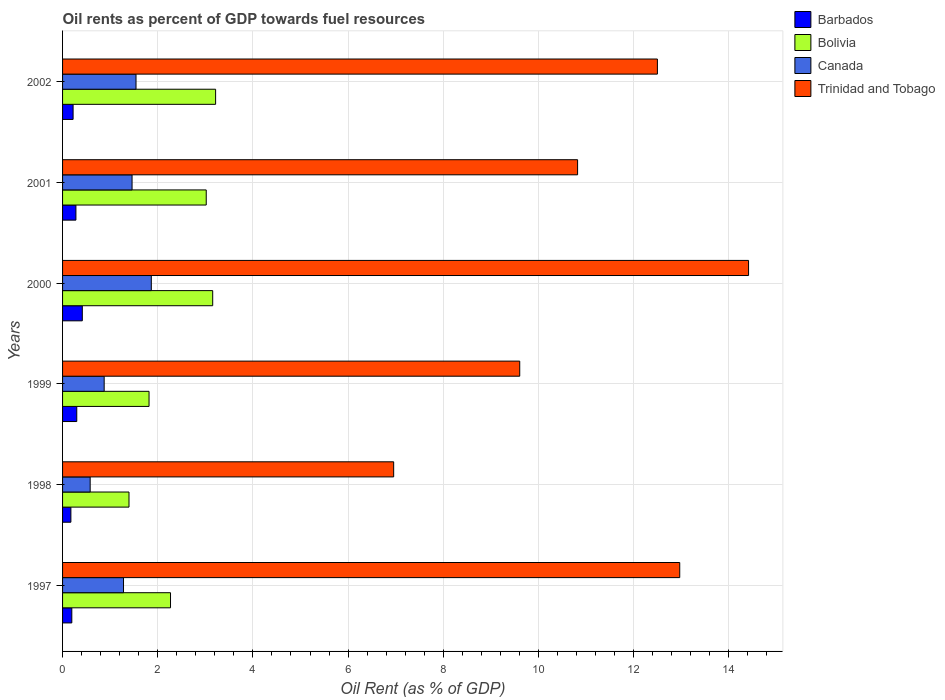Are the number of bars per tick equal to the number of legend labels?
Your answer should be very brief. Yes. Are the number of bars on each tick of the Y-axis equal?
Your answer should be compact. Yes. What is the label of the 5th group of bars from the top?
Make the answer very short. 1998. In how many cases, is the number of bars for a given year not equal to the number of legend labels?
Keep it short and to the point. 0. What is the oil rent in Bolivia in 2002?
Provide a short and direct response. 3.22. Across all years, what is the maximum oil rent in Bolivia?
Your answer should be compact. 3.22. Across all years, what is the minimum oil rent in Canada?
Provide a succinct answer. 0.58. In which year was the oil rent in Barbados maximum?
Ensure brevity in your answer.  2000. In which year was the oil rent in Barbados minimum?
Offer a terse response. 1998. What is the total oil rent in Bolivia in the graph?
Ensure brevity in your answer.  14.87. What is the difference between the oil rent in Barbados in 1997 and that in 2000?
Ensure brevity in your answer.  -0.22. What is the difference between the oil rent in Bolivia in 1997 and the oil rent in Canada in 2001?
Make the answer very short. 0.81. What is the average oil rent in Barbados per year?
Your answer should be very brief. 0.26. In the year 1999, what is the difference between the oil rent in Canada and oil rent in Barbados?
Keep it short and to the point. 0.58. What is the ratio of the oil rent in Bolivia in 1999 to that in 2002?
Your answer should be compact. 0.57. What is the difference between the highest and the second highest oil rent in Barbados?
Offer a very short reply. 0.12. What is the difference between the highest and the lowest oil rent in Trinidad and Tobago?
Ensure brevity in your answer.  7.46. In how many years, is the oil rent in Barbados greater than the average oil rent in Barbados taken over all years?
Ensure brevity in your answer.  3. Is it the case that in every year, the sum of the oil rent in Bolivia and oil rent in Canada is greater than the sum of oil rent in Barbados and oil rent in Trinidad and Tobago?
Ensure brevity in your answer.  Yes. How many bars are there?
Offer a terse response. 24. How many years are there in the graph?
Provide a succinct answer. 6. What is the difference between two consecutive major ticks on the X-axis?
Ensure brevity in your answer.  2. Are the values on the major ticks of X-axis written in scientific E-notation?
Make the answer very short. No. Does the graph contain any zero values?
Your answer should be compact. No. Where does the legend appear in the graph?
Give a very brief answer. Top right. How many legend labels are there?
Provide a succinct answer. 4. How are the legend labels stacked?
Provide a short and direct response. Vertical. What is the title of the graph?
Your answer should be very brief. Oil rents as percent of GDP towards fuel resources. Does "Bahamas" appear as one of the legend labels in the graph?
Provide a succinct answer. No. What is the label or title of the X-axis?
Your answer should be compact. Oil Rent (as % of GDP). What is the Oil Rent (as % of GDP) of Barbados in 1997?
Make the answer very short. 0.19. What is the Oil Rent (as % of GDP) of Bolivia in 1997?
Provide a succinct answer. 2.27. What is the Oil Rent (as % of GDP) of Canada in 1997?
Provide a short and direct response. 1.28. What is the Oil Rent (as % of GDP) of Trinidad and Tobago in 1997?
Your response must be concise. 12.97. What is the Oil Rent (as % of GDP) of Barbados in 1998?
Your response must be concise. 0.18. What is the Oil Rent (as % of GDP) in Bolivia in 1998?
Give a very brief answer. 1.4. What is the Oil Rent (as % of GDP) in Canada in 1998?
Keep it short and to the point. 0.58. What is the Oil Rent (as % of GDP) in Trinidad and Tobago in 1998?
Provide a succinct answer. 6.96. What is the Oil Rent (as % of GDP) in Barbados in 1999?
Provide a short and direct response. 0.3. What is the Oil Rent (as % of GDP) of Bolivia in 1999?
Keep it short and to the point. 1.82. What is the Oil Rent (as % of GDP) in Canada in 1999?
Offer a terse response. 0.87. What is the Oil Rent (as % of GDP) in Trinidad and Tobago in 1999?
Ensure brevity in your answer.  9.61. What is the Oil Rent (as % of GDP) of Barbados in 2000?
Your answer should be compact. 0.41. What is the Oil Rent (as % of GDP) in Bolivia in 2000?
Give a very brief answer. 3.16. What is the Oil Rent (as % of GDP) of Canada in 2000?
Provide a short and direct response. 1.87. What is the Oil Rent (as % of GDP) in Trinidad and Tobago in 2000?
Make the answer very short. 14.42. What is the Oil Rent (as % of GDP) in Barbados in 2001?
Your answer should be compact. 0.28. What is the Oil Rent (as % of GDP) in Bolivia in 2001?
Give a very brief answer. 3.02. What is the Oil Rent (as % of GDP) in Canada in 2001?
Your answer should be compact. 1.46. What is the Oil Rent (as % of GDP) of Trinidad and Tobago in 2001?
Give a very brief answer. 10.82. What is the Oil Rent (as % of GDP) in Barbados in 2002?
Your answer should be compact. 0.22. What is the Oil Rent (as % of GDP) in Bolivia in 2002?
Provide a short and direct response. 3.22. What is the Oil Rent (as % of GDP) in Canada in 2002?
Ensure brevity in your answer.  1.54. What is the Oil Rent (as % of GDP) of Trinidad and Tobago in 2002?
Offer a terse response. 12.5. Across all years, what is the maximum Oil Rent (as % of GDP) of Barbados?
Offer a very short reply. 0.41. Across all years, what is the maximum Oil Rent (as % of GDP) in Bolivia?
Provide a short and direct response. 3.22. Across all years, what is the maximum Oil Rent (as % of GDP) in Canada?
Your answer should be compact. 1.87. Across all years, what is the maximum Oil Rent (as % of GDP) of Trinidad and Tobago?
Ensure brevity in your answer.  14.42. Across all years, what is the minimum Oil Rent (as % of GDP) in Barbados?
Give a very brief answer. 0.18. Across all years, what is the minimum Oil Rent (as % of GDP) in Bolivia?
Ensure brevity in your answer.  1.4. Across all years, what is the minimum Oil Rent (as % of GDP) of Canada?
Ensure brevity in your answer.  0.58. Across all years, what is the minimum Oil Rent (as % of GDP) of Trinidad and Tobago?
Offer a terse response. 6.96. What is the total Oil Rent (as % of GDP) of Barbados in the graph?
Your answer should be very brief. 1.58. What is the total Oil Rent (as % of GDP) of Bolivia in the graph?
Offer a very short reply. 14.87. What is the total Oil Rent (as % of GDP) of Canada in the graph?
Ensure brevity in your answer.  7.6. What is the total Oil Rent (as % of GDP) of Trinidad and Tobago in the graph?
Ensure brevity in your answer.  67.28. What is the difference between the Oil Rent (as % of GDP) of Barbados in 1997 and that in 1998?
Your response must be concise. 0.02. What is the difference between the Oil Rent (as % of GDP) of Bolivia in 1997 and that in 1998?
Keep it short and to the point. 0.87. What is the difference between the Oil Rent (as % of GDP) in Canada in 1997 and that in 1998?
Make the answer very short. 0.7. What is the difference between the Oil Rent (as % of GDP) of Trinidad and Tobago in 1997 and that in 1998?
Your answer should be compact. 6.01. What is the difference between the Oil Rent (as % of GDP) in Barbados in 1997 and that in 1999?
Ensure brevity in your answer.  -0.1. What is the difference between the Oil Rent (as % of GDP) in Bolivia in 1997 and that in 1999?
Ensure brevity in your answer.  0.45. What is the difference between the Oil Rent (as % of GDP) of Canada in 1997 and that in 1999?
Your answer should be very brief. 0.41. What is the difference between the Oil Rent (as % of GDP) in Trinidad and Tobago in 1997 and that in 1999?
Offer a very short reply. 3.36. What is the difference between the Oil Rent (as % of GDP) in Barbados in 1997 and that in 2000?
Provide a succinct answer. -0.22. What is the difference between the Oil Rent (as % of GDP) in Bolivia in 1997 and that in 2000?
Your answer should be compact. -0.89. What is the difference between the Oil Rent (as % of GDP) of Canada in 1997 and that in 2000?
Your response must be concise. -0.58. What is the difference between the Oil Rent (as % of GDP) in Trinidad and Tobago in 1997 and that in 2000?
Your answer should be very brief. -1.45. What is the difference between the Oil Rent (as % of GDP) in Barbados in 1997 and that in 2001?
Give a very brief answer. -0.09. What is the difference between the Oil Rent (as % of GDP) in Bolivia in 1997 and that in 2001?
Offer a terse response. -0.75. What is the difference between the Oil Rent (as % of GDP) in Canada in 1997 and that in 2001?
Keep it short and to the point. -0.18. What is the difference between the Oil Rent (as % of GDP) of Trinidad and Tobago in 1997 and that in 2001?
Offer a terse response. 2.15. What is the difference between the Oil Rent (as % of GDP) in Barbados in 1997 and that in 2002?
Offer a terse response. -0.03. What is the difference between the Oil Rent (as % of GDP) in Bolivia in 1997 and that in 2002?
Give a very brief answer. -0.95. What is the difference between the Oil Rent (as % of GDP) in Canada in 1997 and that in 2002?
Offer a very short reply. -0.26. What is the difference between the Oil Rent (as % of GDP) in Trinidad and Tobago in 1997 and that in 2002?
Your answer should be very brief. 0.47. What is the difference between the Oil Rent (as % of GDP) in Barbados in 1998 and that in 1999?
Your answer should be compact. -0.12. What is the difference between the Oil Rent (as % of GDP) of Bolivia in 1998 and that in 1999?
Your response must be concise. -0.42. What is the difference between the Oil Rent (as % of GDP) in Canada in 1998 and that in 1999?
Make the answer very short. -0.29. What is the difference between the Oil Rent (as % of GDP) in Trinidad and Tobago in 1998 and that in 1999?
Offer a terse response. -2.65. What is the difference between the Oil Rent (as % of GDP) in Barbados in 1998 and that in 2000?
Offer a very short reply. -0.24. What is the difference between the Oil Rent (as % of GDP) in Bolivia in 1998 and that in 2000?
Your answer should be compact. -1.76. What is the difference between the Oil Rent (as % of GDP) of Canada in 1998 and that in 2000?
Ensure brevity in your answer.  -1.28. What is the difference between the Oil Rent (as % of GDP) of Trinidad and Tobago in 1998 and that in 2000?
Offer a very short reply. -7.46. What is the difference between the Oil Rent (as % of GDP) in Barbados in 1998 and that in 2001?
Provide a short and direct response. -0.11. What is the difference between the Oil Rent (as % of GDP) in Bolivia in 1998 and that in 2001?
Your answer should be very brief. -1.62. What is the difference between the Oil Rent (as % of GDP) of Canada in 1998 and that in 2001?
Your response must be concise. -0.88. What is the difference between the Oil Rent (as % of GDP) of Trinidad and Tobago in 1998 and that in 2001?
Offer a very short reply. -3.87. What is the difference between the Oil Rent (as % of GDP) of Barbados in 1998 and that in 2002?
Offer a terse response. -0.05. What is the difference between the Oil Rent (as % of GDP) of Bolivia in 1998 and that in 2002?
Offer a terse response. -1.82. What is the difference between the Oil Rent (as % of GDP) in Canada in 1998 and that in 2002?
Make the answer very short. -0.96. What is the difference between the Oil Rent (as % of GDP) of Trinidad and Tobago in 1998 and that in 2002?
Ensure brevity in your answer.  -5.54. What is the difference between the Oil Rent (as % of GDP) of Barbados in 1999 and that in 2000?
Your answer should be very brief. -0.12. What is the difference between the Oil Rent (as % of GDP) of Bolivia in 1999 and that in 2000?
Your response must be concise. -1.34. What is the difference between the Oil Rent (as % of GDP) of Canada in 1999 and that in 2000?
Your response must be concise. -0.99. What is the difference between the Oil Rent (as % of GDP) of Trinidad and Tobago in 1999 and that in 2000?
Make the answer very short. -4.81. What is the difference between the Oil Rent (as % of GDP) in Barbados in 1999 and that in 2001?
Offer a very short reply. 0.02. What is the difference between the Oil Rent (as % of GDP) of Bolivia in 1999 and that in 2001?
Make the answer very short. -1.2. What is the difference between the Oil Rent (as % of GDP) in Canada in 1999 and that in 2001?
Make the answer very short. -0.59. What is the difference between the Oil Rent (as % of GDP) in Trinidad and Tobago in 1999 and that in 2001?
Your response must be concise. -1.22. What is the difference between the Oil Rent (as % of GDP) in Barbados in 1999 and that in 2002?
Make the answer very short. 0.08. What is the difference between the Oil Rent (as % of GDP) in Bolivia in 1999 and that in 2002?
Ensure brevity in your answer.  -1.4. What is the difference between the Oil Rent (as % of GDP) in Canada in 1999 and that in 2002?
Offer a very short reply. -0.67. What is the difference between the Oil Rent (as % of GDP) in Trinidad and Tobago in 1999 and that in 2002?
Your response must be concise. -2.89. What is the difference between the Oil Rent (as % of GDP) of Barbados in 2000 and that in 2001?
Keep it short and to the point. 0.13. What is the difference between the Oil Rent (as % of GDP) of Bolivia in 2000 and that in 2001?
Your response must be concise. 0.14. What is the difference between the Oil Rent (as % of GDP) of Canada in 2000 and that in 2001?
Ensure brevity in your answer.  0.4. What is the difference between the Oil Rent (as % of GDP) in Trinidad and Tobago in 2000 and that in 2001?
Keep it short and to the point. 3.59. What is the difference between the Oil Rent (as % of GDP) of Barbados in 2000 and that in 2002?
Offer a very short reply. 0.19. What is the difference between the Oil Rent (as % of GDP) of Bolivia in 2000 and that in 2002?
Offer a terse response. -0.06. What is the difference between the Oil Rent (as % of GDP) in Canada in 2000 and that in 2002?
Offer a terse response. 0.32. What is the difference between the Oil Rent (as % of GDP) in Trinidad and Tobago in 2000 and that in 2002?
Offer a terse response. 1.92. What is the difference between the Oil Rent (as % of GDP) in Barbados in 2001 and that in 2002?
Keep it short and to the point. 0.06. What is the difference between the Oil Rent (as % of GDP) in Bolivia in 2001 and that in 2002?
Your answer should be compact. -0.2. What is the difference between the Oil Rent (as % of GDP) of Canada in 2001 and that in 2002?
Ensure brevity in your answer.  -0.08. What is the difference between the Oil Rent (as % of GDP) in Trinidad and Tobago in 2001 and that in 2002?
Your answer should be compact. -1.68. What is the difference between the Oil Rent (as % of GDP) in Barbados in 1997 and the Oil Rent (as % of GDP) in Bolivia in 1998?
Offer a very short reply. -1.2. What is the difference between the Oil Rent (as % of GDP) in Barbados in 1997 and the Oil Rent (as % of GDP) in Canada in 1998?
Offer a very short reply. -0.39. What is the difference between the Oil Rent (as % of GDP) of Barbados in 1997 and the Oil Rent (as % of GDP) of Trinidad and Tobago in 1998?
Make the answer very short. -6.76. What is the difference between the Oil Rent (as % of GDP) of Bolivia in 1997 and the Oil Rent (as % of GDP) of Canada in 1998?
Offer a terse response. 1.69. What is the difference between the Oil Rent (as % of GDP) of Bolivia in 1997 and the Oil Rent (as % of GDP) of Trinidad and Tobago in 1998?
Keep it short and to the point. -4.69. What is the difference between the Oil Rent (as % of GDP) of Canada in 1997 and the Oil Rent (as % of GDP) of Trinidad and Tobago in 1998?
Give a very brief answer. -5.68. What is the difference between the Oil Rent (as % of GDP) of Barbados in 1997 and the Oil Rent (as % of GDP) of Bolivia in 1999?
Provide a succinct answer. -1.62. What is the difference between the Oil Rent (as % of GDP) in Barbados in 1997 and the Oil Rent (as % of GDP) in Canada in 1999?
Provide a succinct answer. -0.68. What is the difference between the Oil Rent (as % of GDP) in Barbados in 1997 and the Oil Rent (as % of GDP) in Trinidad and Tobago in 1999?
Make the answer very short. -9.41. What is the difference between the Oil Rent (as % of GDP) in Bolivia in 1997 and the Oil Rent (as % of GDP) in Canada in 1999?
Make the answer very short. 1.39. What is the difference between the Oil Rent (as % of GDP) of Bolivia in 1997 and the Oil Rent (as % of GDP) of Trinidad and Tobago in 1999?
Offer a terse response. -7.34. What is the difference between the Oil Rent (as % of GDP) in Canada in 1997 and the Oil Rent (as % of GDP) in Trinidad and Tobago in 1999?
Offer a terse response. -8.33. What is the difference between the Oil Rent (as % of GDP) of Barbados in 1997 and the Oil Rent (as % of GDP) of Bolivia in 2000?
Provide a succinct answer. -2.96. What is the difference between the Oil Rent (as % of GDP) of Barbados in 1997 and the Oil Rent (as % of GDP) of Canada in 2000?
Provide a short and direct response. -1.67. What is the difference between the Oil Rent (as % of GDP) in Barbados in 1997 and the Oil Rent (as % of GDP) in Trinidad and Tobago in 2000?
Offer a terse response. -14.22. What is the difference between the Oil Rent (as % of GDP) of Bolivia in 1997 and the Oil Rent (as % of GDP) of Canada in 2000?
Your response must be concise. 0.4. What is the difference between the Oil Rent (as % of GDP) of Bolivia in 1997 and the Oil Rent (as % of GDP) of Trinidad and Tobago in 2000?
Provide a succinct answer. -12.15. What is the difference between the Oil Rent (as % of GDP) in Canada in 1997 and the Oil Rent (as % of GDP) in Trinidad and Tobago in 2000?
Provide a short and direct response. -13.14. What is the difference between the Oil Rent (as % of GDP) of Barbados in 1997 and the Oil Rent (as % of GDP) of Bolivia in 2001?
Your response must be concise. -2.83. What is the difference between the Oil Rent (as % of GDP) of Barbados in 1997 and the Oil Rent (as % of GDP) of Canada in 2001?
Your response must be concise. -1.27. What is the difference between the Oil Rent (as % of GDP) of Barbados in 1997 and the Oil Rent (as % of GDP) of Trinidad and Tobago in 2001?
Make the answer very short. -10.63. What is the difference between the Oil Rent (as % of GDP) of Bolivia in 1997 and the Oil Rent (as % of GDP) of Canada in 2001?
Offer a terse response. 0.81. What is the difference between the Oil Rent (as % of GDP) of Bolivia in 1997 and the Oil Rent (as % of GDP) of Trinidad and Tobago in 2001?
Provide a short and direct response. -8.56. What is the difference between the Oil Rent (as % of GDP) in Canada in 1997 and the Oil Rent (as % of GDP) in Trinidad and Tobago in 2001?
Your response must be concise. -9.54. What is the difference between the Oil Rent (as % of GDP) of Barbados in 1997 and the Oil Rent (as % of GDP) of Bolivia in 2002?
Ensure brevity in your answer.  -3.02. What is the difference between the Oil Rent (as % of GDP) in Barbados in 1997 and the Oil Rent (as % of GDP) in Canada in 2002?
Your response must be concise. -1.35. What is the difference between the Oil Rent (as % of GDP) of Barbados in 1997 and the Oil Rent (as % of GDP) of Trinidad and Tobago in 2002?
Provide a succinct answer. -12.31. What is the difference between the Oil Rent (as % of GDP) in Bolivia in 1997 and the Oil Rent (as % of GDP) in Canada in 2002?
Your response must be concise. 0.72. What is the difference between the Oil Rent (as % of GDP) in Bolivia in 1997 and the Oil Rent (as % of GDP) in Trinidad and Tobago in 2002?
Your answer should be compact. -10.23. What is the difference between the Oil Rent (as % of GDP) of Canada in 1997 and the Oil Rent (as % of GDP) of Trinidad and Tobago in 2002?
Provide a succinct answer. -11.22. What is the difference between the Oil Rent (as % of GDP) of Barbados in 1998 and the Oil Rent (as % of GDP) of Bolivia in 1999?
Keep it short and to the point. -1.64. What is the difference between the Oil Rent (as % of GDP) of Barbados in 1998 and the Oil Rent (as % of GDP) of Canada in 1999?
Provide a succinct answer. -0.7. What is the difference between the Oil Rent (as % of GDP) of Barbados in 1998 and the Oil Rent (as % of GDP) of Trinidad and Tobago in 1999?
Ensure brevity in your answer.  -9.43. What is the difference between the Oil Rent (as % of GDP) in Bolivia in 1998 and the Oil Rent (as % of GDP) in Canada in 1999?
Your answer should be very brief. 0.52. What is the difference between the Oil Rent (as % of GDP) of Bolivia in 1998 and the Oil Rent (as % of GDP) of Trinidad and Tobago in 1999?
Make the answer very short. -8.21. What is the difference between the Oil Rent (as % of GDP) of Canada in 1998 and the Oil Rent (as % of GDP) of Trinidad and Tobago in 1999?
Provide a succinct answer. -9.03. What is the difference between the Oil Rent (as % of GDP) of Barbados in 1998 and the Oil Rent (as % of GDP) of Bolivia in 2000?
Provide a short and direct response. -2.98. What is the difference between the Oil Rent (as % of GDP) of Barbados in 1998 and the Oil Rent (as % of GDP) of Canada in 2000?
Provide a succinct answer. -1.69. What is the difference between the Oil Rent (as % of GDP) in Barbados in 1998 and the Oil Rent (as % of GDP) in Trinidad and Tobago in 2000?
Provide a succinct answer. -14.24. What is the difference between the Oil Rent (as % of GDP) in Bolivia in 1998 and the Oil Rent (as % of GDP) in Canada in 2000?
Your answer should be compact. -0.47. What is the difference between the Oil Rent (as % of GDP) in Bolivia in 1998 and the Oil Rent (as % of GDP) in Trinidad and Tobago in 2000?
Provide a succinct answer. -13.02. What is the difference between the Oil Rent (as % of GDP) in Canada in 1998 and the Oil Rent (as % of GDP) in Trinidad and Tobago in 2000?
Your answer should be compact. -13.84. What is the difference between the Oil Rent (as % of GDP) of Barbados in 1998 and the Oil Rent (as % of GDP) of Bolivia in 2001?
Your response must be concise. -2.84. What is the difference between the Oil Rent (as % of GDP) in Barbados in 1998 and the Oil Rent (as % of GDP) in Canada in 2001?
Provide a short and direct response. -1.29. What is the difference between the Oil Rent (as % of GDP) of Barbados in 1998 and the Oil Rent (as % of GDP) of Trinidad and Tobago in 2001?
Offer a very short reply. -10.65. What is the difference between the Oil Rent (as % of GDP) of Bolivia in 1998 and the Oil Rent (as % of GDP) of Canada in 2001?
Offer a very short reply. -0.06. What is the difference between the Oil Rent (as % of GDP) of Bolivia in 1998 and the Oil Rent (as % of GDP) of Trinidad and Tobago in 2001?
Give a very brief answer. -9.43. What is the difference between the Oil Rent (as % of GDP) in Canada in 1998 and the Oil Rent (as % of GDP) in Trinidad and Tobago in 2001?
Make the answer very short. -10.24. What is the difference between the Oil Rent (as % of GDP) in Barbados in 1998 and the Oil Rent (as % of GDP) in Bolivia in 2002?
Offer a terse response. -3.04. What is the difference between the Oil Rent (as % of GDP) in Barbados in 1998 and the Oil Rent (as % of GDP) in Canada in 2002?
Your answer should be compact. -1.37. What is the difference between the Oil Rent (as % of GDP) of Barbados in 1998 and the Oil Rent (as % of GDP) of Trinidad and Tobago in 2002?
Offer a terse response. -12.33. What is the difference between the Oil Rent (as % of GDP) in Bolivia in 1998 and the Oil Rent (as % of GDP) in Canada in 2002?
Your answer should be very brief. -0.15. What is the difference between the Oil Rent (as % of GDP) of Bolivia in 1998 and the Oil Rent (as % of GDP) of Trinidad and Tobago in 2002?
Your answer should be compact. -11.11. What is the difference between the Oil Rent (as % of GDP) in Canada in 1998 and the Oil Rent (as % of GDP) in Trinidad and Tobago in 2002?
Keep it short and to the point. -11.92. What is the difference between the Oil Rent (as % of GDP) in Barbados in 1999 and the Oil Rent (as % of GDP) in Bolivia in 2000?
Your answer should be compact. -2.86. What is the difference between the Oil Rent (as % of GDP) of Barbados in 1999 and the Oil Rent (as % of GDP) of Canada in 2000?
Your response must be concise. -1.57. What is the difference between the Oil Rent (as % of GDP) in Barbados in 1999 and the Oil Rent (as % of GDP) in Trinidad and Tobago in 2000?
Your answer should be very brief. -14.12. What is the difference between the Oil Rent (as % of GDP) in Bolivia in 1999 and the Oil Rent (as % of GDP) in Canada in 2000?
Offer a terse response. -0.05. What is the difference between the Oil Rent (as % of GDP) in Bolivia in 1999 and the Oil Rent (as % of GDP) in Trinidad and Tobago in 2000?
Ensure brevity in your answer.  -12.6. What is the difference between the Oil Rent (as % of GDP) of Canada in 1999 and the Oil Rent (as % of GDP) of Trinidad and Tobago in 2000?
Ensure brevity in your answer.  -13.54. What is the difference between the Oil Rent (as % of GDP) in Barbados in 1999 and the Oil Rent (as % of GDP) in Bolivia in 2001?
Your response must be concise. -2.72. What is the difference between the Oil Rent (as % of GDP) in Barbados in 1999 and the Oil Rent (as % of GDP) in Canada in 2001?
Offer a very short reply. -1.16. What is the difference between the Oil Rent (as % of GDP) of Barbados in 1999 and the Oil Rent (as % of GDP) of Trinidad and Tobago in 2001?
Ensure brevity in your answer.  -10.53. What is the difference between the Oil Rent (as % of GDP) in Bolivia in 1999 and the Oil Rent (as % of GDP) in Canada in 2001?
Your answer should be compact. 0.36. What is the difference between the Oil Rent (as % of GDP) in Bolivia in 1999 and the Oil Rent (as % of GDP) in Trinidad and Tobago in 2001?
Provide a short and direct response. -9.01. What is the difference between the Oil Rent (as % of GDP) in Canada in 1999 and the Oil Rent (as % of GDP) in Trinidad and Tobago in 2001?
Provide a short and direct response. -9.95. What is the difference between the Oil Rent (as % of GDP) of Barbados in 1999 and the Oil Rent (as % of GDP) of Bolivia in 2002?
Your answer should be very brief. -2.92. What is the difference between the Oil Rent (as % of GDP) in Barbados in 1999 and the Oil Rent (as % of GDP) in Canada in 2002?
Your response must be concise. -1.25. What is the difference between the Oil Rent (as % of GDP) in Barbados in 1999 and the Oil Rent (as % of GDP) in Trinidad and Tobago in 2002?
Provide a short and direct response. -12.2. What is the difference between the Oil Rent (as % of GDP) of Bolivia in 1999 and the Oil Rent (as % of GDP) of Canada in 2002?
Your response must be concise. 0.27. What is the difference between the Oil Rent (as % of GDP) in Bolivia in 1999 and the Oil Rent (as % of GDP) in Trinidad and Tobago in 2002?
Offer a terse response. -10.68. What is the difference between the Oil Rent (as % of GDP) in Canada in 1999 and the Oil Rent (as % of GDP) in Trinidad and Tobago in 2002?
Offer a very short reply. -11.63. What is the difference between the Oil Rent (as % of GDP) of Barbados in 2000 and the Oil Rent (as % of GDP) of Bolivia in 2001?
Ensure brevity in your answer.  -2.6. What is the difference between the Oil Rent (as % of GDP) in Barbados in 2000 and the Oil Rent (as % of GDP) in Canada in 2001?
Offer a very short reply. -1.05. What is the difference between the Oil Rent (as % of GDP) in Barbados in 2000 and the Oil Rent (as % of GDP) in Trinidad and Tobago in 2001?
Provide a succinct answer. -10.41. What is the difference between the Oil Rent (as % of GDP) in Bolivia in 2000 and the Oil Rent (as % of GDP) in Canada in 2001?
Offer a very short reply. 1.69. What is the difference between the Oil Rent (as % of GDP) in Bolivia in 2000 and the Oil Rent (as % of GDP) in Trinidad and Tobago in 2001?
Ensure brevity in your answer.  -7.67. What is the difference between the Oil Rent (as % of GDP) of Canada in 2000 and the Oil Rent (as % of GDP) of Trinidad and Tobago in 2001?
Provide a succinct answer. -8.96. What is the difference between the Oil Rent (as % of GDP) in Barbados in 2000 and the Oil Rent (as % of GDP) in Bolivia in 2002?
Your answer should be compact. -2.8. What is the difference between the Oil Rent (as % of GDP) of Barbados in 2000 and the Oil Rent (as % of GDP) of Canada in 2002?
Provide a succinct answer. -1.13. What is the difference between the Oil Rent (as % of GDP) in Barbados in 2000 and the Oil Rent (as % of GDP) in Trinidad and Tobago in 2002?
Make the answer very short. -12.09. What is the difference between the Oil Rent (as % of GDP) in Bolivia in 2000 and the Oil Rent (as % of GDP) in Canada in 2002?
Offer a very short reply. 1.61. What is the difference between the Oil Rent (as % of GDP) of Bolivia in 2000 and the Oil Rent (as % of GDP) of Trinidad and Tobago in 2002?
Give a very brief answer. -9.35. What is the difference between the Oil Rent (as % of GDP) of Canada in 2000 and the Oil Rent (as % of GDP) of Trinidad and Tobago in 2002?
Provide a succinct answer. -10.64. What is the difference between the Oil Rent (as % of GDP) in Barbados in 2001 and the Oil Rent (as % of GDP) in Bolivia in 2002?
Make the answer very short. -2.94. What is the difference between the Oil Rent (as % of GDP) of Barbados in 2001 and the Oil Rent (as % of GDP) of Canada in 2002?
Make the answer very short. -1.26. What is the difference between the Oil Rent (as % of GDP) of Barbados in 2001 and the Oil Rent (as % of GDP) of Trinidad and Tobago in 2002?
Give a very brief answer. -12.22. What is the difference between the Oil Rent (as % of GDP) of Bolivia in 2001 and the Oil Rent (as % of GDP) of Canada in 2002?
Offer a very short reply. 1.48. What is the difference between the Oil Rent (as % of GDP) in Bolivia in 2001 and the Oil Rent (as % of GDP) in Trinidad and Tobago in 2002?
Give a very brief answer. -9.48. What is the difference between the Oil Rent (as % of GDP) in Canada in 2001 and the Oil Rent (as % of GDP) in Trinidad and Tobago in 2002?
Provide a succinct answer. -11.04. What is the average Oil Rent (as % of GDP) of Barbados per year?
Your answer should be very brief. 0.26. What is the average Oil Rent (as % of GDP) in Bolivia per year?
Offer a very short reply. 2.48. What is the average Oil Rent (as % of GDP) of Canada per year?
Offer a terse response. 1.27. What is the average Oil Rent (as % of GDP) of Trinidad and Tobago per year?
Provide a short and direct response. 11.21. In the year 1997, what is the difference between the Oil Rent (as % of GDP) in Barbados and Oil Rent (as % of GDP) in Bolivia?
Make the answer very short. -2.07. In the year 1997, what is the difference between the Oil Rent (as % of GDP) of Barbados and Oil Rent (as % of GDP) of Canada?
Your response must be concise. -1.09. In the year 1997, what is the difference between the Oil Rent (as % of GDP) in Barbados and Oil Rent (as % of GDP) in Trinidad and Tobago?
Your response must be concise. -12.78. In the year 1997, what is the difference between the Oil Rent (as % of GDP) in Bolivia and Oil Rent (as % of GDP) in Canada?
Your answer should be very brief. 0.99. In the year 1997, what is the difference between the Oil Rent (as % of GDP) in Bolivia and Oil Rent (as % of GDP) in Trinidad and Tobago?
Provide a succinct answer. -10.7. In the year 1997, what is the difference between the Oil Rent (as % of GDP) in Canada and Oil Rent (as % of GDP) in Trinidad and Tobago?
Keep it short and to the point. -11.69. In the year 1998, what is the difference between the Oil Rent (as % of GDP) of Barbados and Oil Rent (as % of GDP) of Bolivia?
Provide a short and direct response. -1.22. In the year 1998, what is the difference between the Oil Rent (as % of GDP) in Barbados and Oil Rent (as % of GDP) in Canada?
Keep it short and to the point. -0.41. In the year 1998, what is the difference between the Oil Rent (as % of GDP) of Barbados and Oil Rent (as % of GDP) of Trinidad and Tobago?
Give a very brief answer. -6.78. In the year 1998, what is the difference between the Oil Rent (as % of GDP) in Bolivia and Oil Rent (as % of GDP) in Canada?
Your answer should be compact. 0.82. In the year 1998, what is the difference between the Oil Rent (as % of GDP) in Bolivia and Oil Rent (as % of GDP) in Trinidad and Tobago?
Offer a terse response. -5.56. In the year 1998, what is the difference between the Oil Rent (as % of GDP) in Canada and Oil Rent (as % of GDP) in Trinidad and Tobago?
Give a very brief answer. -6.38. In the year 1999, what is the difference between the Oil Rent (as % of GDP) in Barbados and Oil Rent (as % of GDP) in Bolivia?
Give a very brief answer. -1.52. In the year 1999, what is the difference between the Oil Rent (as % of GDP) of Barbados and Oil Rent (as % of GDP) of Canada?
Your response must be concise. -0.58. In the year 1999, what is the difference between the Oil Rent (as % of GDP) in Barbados and Oil Rent (as % of GDP) in Trinidad and Tobago?
Provide a short and direct response. -9.31. In the year 1999, what is the difference between the Oil Rent (as % of GDP) in Bolivia and Oil Rent (as % of GDP) in Canada?
Give a very brief answer. 0.94. In the year 1999, what is the difference between the Oil Rent (as % of GDP) of Bolivia and Oil Rent (as % of GDP) of Trinidad and Tobago?
Your answer should be very brief. -7.79. In the year 1999, what is the difference between the Oil Rent (as % of GDP) of Canada and Oil Rent (as % of GDP) of Trinidad and Tobago?
Give a very brief answer. -8.73. In the year 2000, what is the difference between the Oil Rent (as % of GDP) in Barbados and Oil Rent (as % of GDP) in Bolivia?
Give a very brief answer. -2.74. In the year 2000, what is the difference between the Oil Rent (as % of GDP) of Barbados and Oil Rent (as % of GDP) of Canada?
Your answer should be very brief. -1.45. In the year 2000, what is the difference between the Oil Rent (as % of GDP) of Barbados and Oil Rent (as % of GDP) of Trinidad and Tobago?
Offer a very short reply. -14. In the year 2000, what is the difference between the Oil Rent (as % of GDP) in Bolivia and Oil Rent (as % of GDP) in Canada?
Provide a succinct answer. 1.29. In the year 2000, what is the difference between the Oil Rent (as % of GDP) in Bolivia and Oil Rent (as % of GDP) in Trinidad and Tobago?
Keep it short and to the point. -11.26. In the year 2000, what is the difference between the Oil Rent (as % of GDP) of Canada and Oil Rent (as % of GDP) of Trinidad and Tobago?
Offer a terse response. -12.55. In the year 2001, what is the difference between the Oil Rent (as % of GDP) of Barbados and Oil Rent (as % of GDP) of Bolivia?
Offer a very short reply. -2.74. In the year 2001, what is the difference between the Oil Rent (as % of GDP) in Barbados and Oil Rent (as % of GDP) in Canada?
Provide a succinct answer. -1.18. In the year 2001, what is the difference between the Oil Rent (as % of GDP) of Barbados and Oil Rent (as % of GDP) of Trinidad and Tobago?
Ensure brevity in your answer.  -10.54. In the year 2001, what is the difference between the Oil Rent (as % of GDP) of Bolivia and Oil Rent (as % of GDP) of Canada?
Offer a terse response. 1.56. In the year 2001, what is the difference between the Oil Rent (as % of GDP) of Bolivia and Oil Rent (as % of GDP) of Trinidad and Tobago?
Ensure brevity in your answer.  -7.8. In the year 2001, what is the difference between the Oil Rent (as % of GDP) of Canada and Oil Rent (as % of GDP) of Trinidad and Tobago?
Make the answer very short. -9.36. In the year 2002, what is the difference between the Oil Rent (as % of GDP) of Barbados and Oil Rent (as % of GDP) of Bolivia?
Provide a succinct answer. -3. In the year 2002, what is the difference between the Oil Rent (as % of GDP) in Barbados and Oil Rent (as % of GDP) in Canada?
Give a very brief answer. -1.32. In the year 2002, what is the difference between the Oil Rent (as % of GDP) in Barbados and Oil Rent (as % of GDP) in Trinidad and Tobago?
Offer a very short reply. -12.28. In the year 2002, what is the difference between the Oil Rent (as % of GDP) of Bolivia and Oil Rent (as % of GDP) of Canada?
Ensure brevity in your answer.  1.67. In the year 2002, what is the difference between the Oil Rent (as % of GDP) of Bolivia and Oil Rent (as % of GDP) of Trinidad and Tobago?
Offer a terse response. -9.28. In the year 2002, what is the difference between the Oil Rent (as % of GDP) of Canada and Oil Rent (as % of GDP) of Trinidad and Tobago?
Offer a terse response. -10.96. What is the ratio of the Oil Rent (as % of GDP) of Barbados in 1997 to that in 1998?
Your response must be concise. 1.11. What is the ratio of the Oil Rent (as % of GDP) in Bolivia in 1997 to that in 1998?
Provide a short and direct response. 1.62. What is the ratio of the Oil Rent (as % of GDP) in Canada in 1997 to that in 1998?
Offer a very short reply. 2.21. What is the ratio of the Oil Rent (as % of GDP) in Trinidad and Tobago in 1997 to that in 1998?
Provide a succinct answer. 1.86. What is the ratio of the Oil Rent (as % of GDP) of Barbados in 1997 to that in 1999?
Your answer should be very brief. 0.65. What is the ratio of the Oil Rent (as % of GDP) in Bolivia in 1997 to that in 1999?
Your answer should be very brief. 1.25. What is the ratio of the Oil Rent (as % of GDP) of Canada in 1997 to that in 1999?
Your answer should be very brief. 1.47. What is the ratio of the Oil Rent (as % of GDP) in Trinidad and Tobago in 1997 to that in 1999?
Ensure brevity in your answer.  1.35. What is the ratio of the Oil Rent (as % of GDP) in Barbados in 1997 to that in 2000?
Keep it short and to the point. 0.47. What is the ratio of the Oil Rent (as % of GDP) of Bolivia in 1997 to that in 2000?
Ensure brevity in your answer.  0.72. What is the ratio of the Oil Rent (as % of GDP) of Canada in 1997 to that in 2000?
Ensure brevity in your answer.  0.69. What is the ratio of the Oil Rent (as % of GDP) in Trinidad and Tobago in 1997 to that in 2000?
Keep it short and to the point. 0.9. What is the ratio of the Oil Rent (as % of GDP) in Barbados in 1997 to that in 2001?
Your response must be concise. 0.69. What is the ratio of the Oil Rent (as % of GDP) of Bolivia in 1997 to that in 2001?
Your response must be concise. 0.75. What is the ratio of the Oil Rent (as % of GDP) of Canada in 1997 to that in 2001?
Your answer should be very brief. 0.88. What is the ratio of the Oil Rent (as % of GDP) in Trinidad and Tobago in 1997 to that in 2001?
Provide a succinct answer. 1.2. What is the ratio of the Oil Rent (as % of GDP) in Barbados in 1997 to that in 2002?
Ensure brevity in your answer.  0.88. What is the ratio of the Oil Rent (as % of GDP) in Bolivia in 1997 to that in 2002?
Offer a terse response. 0.71. What is the ratio of the Oil Rent (as % of GDP) of Canada in 1997 to that in 2002?
Offer a very short reply. 0.83. What is the ratio of the Oil Rent (as % of GDP) of Trinidad and Tobago in 1997 to that in 2002?
Provide a short and direct response. 1.04. What is the ratio of the Oil Rent (as % of GDP) of Barbados in 1998 to that in 1999?
Your response must be concise. 0.59. What is the ratio of the Oil Rent (as % of GDP) of Bolivia in 1998 to that in 1999?
Offer a terse response. 0.77. What is the ratio of the Oil Rent (as % of GDP) in Canada in 1998 to that in 1999?
Make the answer very short. 0.66. What is the ratio of the Oil Rent (as % of GDP) of Trinidad and Tobago in 1998 to that in 1999?
Your answer should be compact. 0.72. What is the ratio of the Oil Rent (as % of GDP) in Barbados in 1998 to that in 2000?
Provide a short and direct response. 0.42. What is the ratio of the Oil Rent (as % of GDP) in Bolivia in 1998 to that in 2000?
Your answer should be compact. 0.44. What is the ratio of the Oil Rent (as % of GDP) in Canada in 1998 to that in 2000?
Provide a short and direct response. 0.31. What is the ratio of the Oil Rent (as % of GDP) of Trinidad and Tobago in 1998 to that in 2000?
Make the answer very short. 0.48. What is the ratio of the Oil Rent (as % of GDP) of Barbados in 1998 to that in 2001?
Your response must be concise. 0.62. What is the ratio of the Oil Rent (as % of GDP) of Bolivia in 1998 to that in 2001?
Keep it short and to the point. 0.46. What is the ratio of the Oil Rent (as % of GDP) in Canada in 1998 to that in 2001?
Ensure brevity in your answer.  0.4. What is the ratio of the Oil Rent (as % of GDP) in Trinidad and Tobago in 1998 to that in 2001?
Ensure brevity in your answer.  0.64. What is the ratio of the Oil Rent (as % of GDP) of Barbados in 1998 to that in 2002?
Provide a succinct answer. 0.79. What is the ratio of the Oil Rent (as % of GDP) in Bolivia in 1998 to that in 2002?
Offer a very short reply. 0.43. What is the ratio of the Oil Rent (as % of GDP) of Canada in 1998 to that in 2002?
Provide a short and direct response. 0.38. What is the ratio of the Oil Rent (as % of GDP) in Trinidad and Tobago in 1998 to that in 2002?
Provide a succinct answer. 0.56. What is the ratio of the Oil Rent (as % of GDP) in Barbados in 1999 to that in 2000?
Your answer should be very brief. 0.72. What is the ratio of the Oil Rent (as % of GDP) of Bolivia in 1999 to that in 2000?
Provide a short and direct response. 0.58. What is the ratio of the Oil Rent (as % of GDP) in Canada in 1999 to that in 2000?
Your answer should be compact. 0.47. What is the ratio of the Oil Rent (as % of GDP) of Trinidad and Tobago in 1999 to that in 2000?
Ensure brevity in your answer.  0.67. What is the ratio of the Oil Rent (as % of GDP) in Barbados in 1999 to that in 2001?
Provide a short and direct response. 1.06. What is the ratio of the Oil Rent (as % of GDP) of Bolivia in 1999 to that in 2001?
Ensure brevity in your answer.  0.6. What is the ratio of the Oil Rent (as % of GDP) in Canada in 1999 to that in 2001?
Make the answer very short. 0.6. What is the ratio of the Oil Rent (as % of GDP) in Trinidad and Tobago in 1999 to that in 2001?
Give a very brief answer. 0.89. What is the ratio of the Oil Rent (as % of GDP) of Barbados in 1999 to that in 2002?
Provide a short and direct response. 1.35. What is the ratio of the Oil Rent (as % of GDP) in Bolivia in 1999 to that in 2002?
Give a very brief answer. 0.57. What is the ratio of the Oil Rent (as % of GDP) in Canada in 1999 to that in 2002?
Ensure brevity in your answer.  0.57. What is the ratio of the Oil Rent (as % of GDP) of Trinidad and Tobago in 1999 to that in 2002?
Provide a short and direct response. 0.77. What is the ratio of the Oil Rent (as % of GDP) of Barbados in 2000 to that in 2001?
Give a very brief answer. 1.48. What is the ratio of the Oil Rent (as % of GDP) in Bolivia in 2000 to that in 2001?
Your answer should be compact. 1.04. What is the ratio of the Oil Rent (as % of GDP) in Canada in 2000 to that in 2001?
Ensure brevity in your answer.  1.28. What is the ratio of the Oil Rent (as % of GDP) of Trinidad and Tobago in 2000 to that in 2001?
Ensure brevity in your answer.  1.33. What is the ratio of the Oil Rent (as % of GDP) of Barbados in 2000 to that in 2002?
Your answer should be compact. 1.88. What is the ratio of the Oil Rent (as % of GDP) in Bolivia in 2000 to that in 2002?
Provide a succinct answer. 0.98. What is the ratio of the Oil Rent (as % of GDP) in Canada in 2000 to that in 2002?
Ensure brevity in your answer.  1.21. What is the ratio of the Oil Rent (as % of GDP) in Trinidad and Tobago in 2000 to that in 2002?
Give a very brief answer. 1.15. What is the ratio of the Oil Rent (as % of GDP) of Barbados in 2001 to that in 2002?
Offer a terse response. 1.27. What is the ratio of the Oil Rent (as % of GDP) in Bolivia in 2001 to that in 2002?
Your answer should be compact. 0.94. What is the ratio of the Oil Rent (as % of GDP) in Canada in 2001 to that in 2002?
Offer a terse response. 0.95. What is the ratio of the Oil Rent (as % of GDP) of Trinidad and Tobago in 2001 to that in 2002?
Provide a succinct answer. 0.87. What is the difference between the highest and the second highest Oil Rent (as % of GDP) in Barbados?
Give a very brief answer. 0.12. What is the difference between the highest and the second highest Oil Rent (as % of GDP) of Bolivia?
Provide a short and direct response. 0.06. What is the difference between the highest and the second highest Oil Rent (as % of GDP) of Canada?
Provide a short and direct response. 0.32. What is the difference between the highest and the second highest Oil Rent (as % of GDP) in Trinidad and Tobago?
Your answer should be compact. 1.45. What is the difference between the highest and the lowest Oil Rent (as % of GDP) in Barbados?
Make the answer very short. 0.24. What is the difference between the highest and the lowest Oil Rent (as % of GDP) of Bolivia?
Provide a short and direct response. 1.82. What is the difference between the highest and the lowest Oil Rent (as % of GDP) in Canada?
Offer a very short reply. 1.28. What is the difference between the highest and the lowest Oil Rent (as % of GDP) of Trinidad and Tobago?
Offer a very short reply. 7.46. 